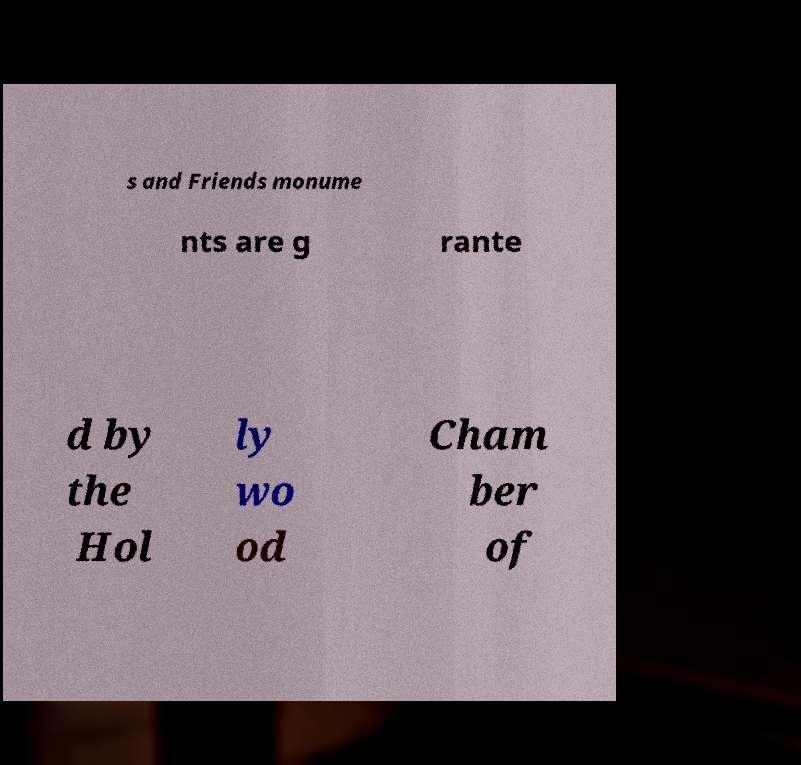Please identify and transcribe the text found in this image. s and Friends monume nts are g rante d by the Hol ly wo od Cham ber of 